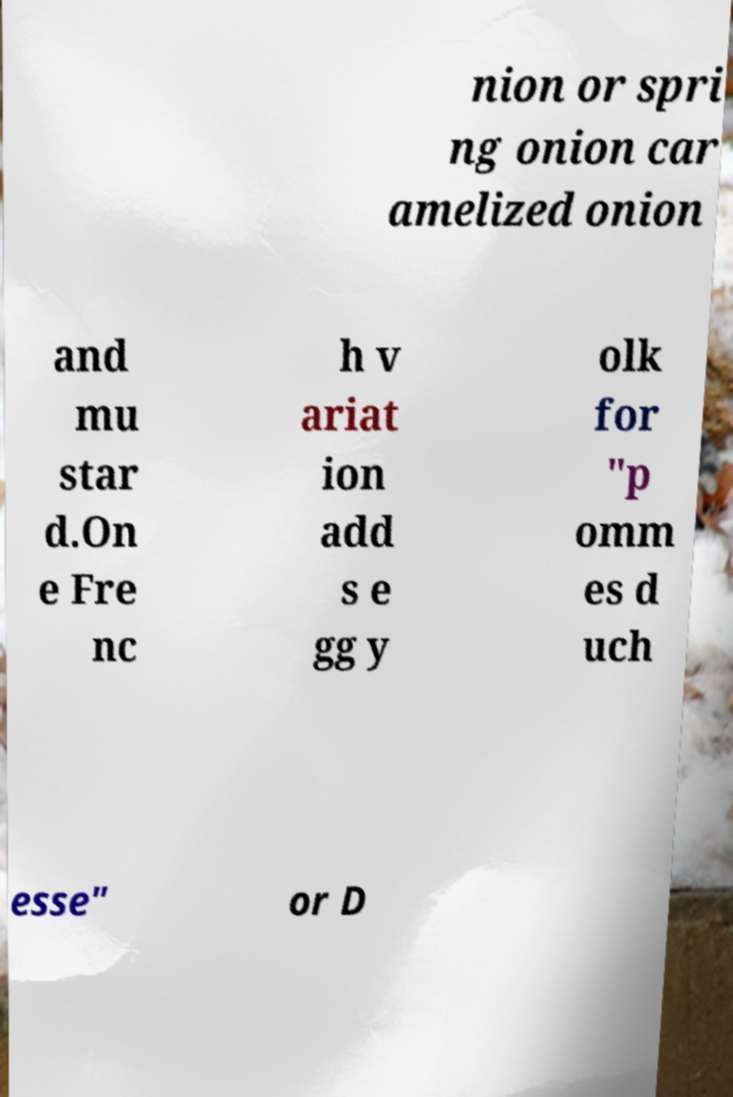Can you read and provide the text displayed in the image?This photo seems to have some interesting text. Can you extract and type it out for me? nion or spri ng onion car amelized onion and mu star d.On e Fre nc h v ariat ion add s e gg y olk for "p omm es d uch esse" or D 